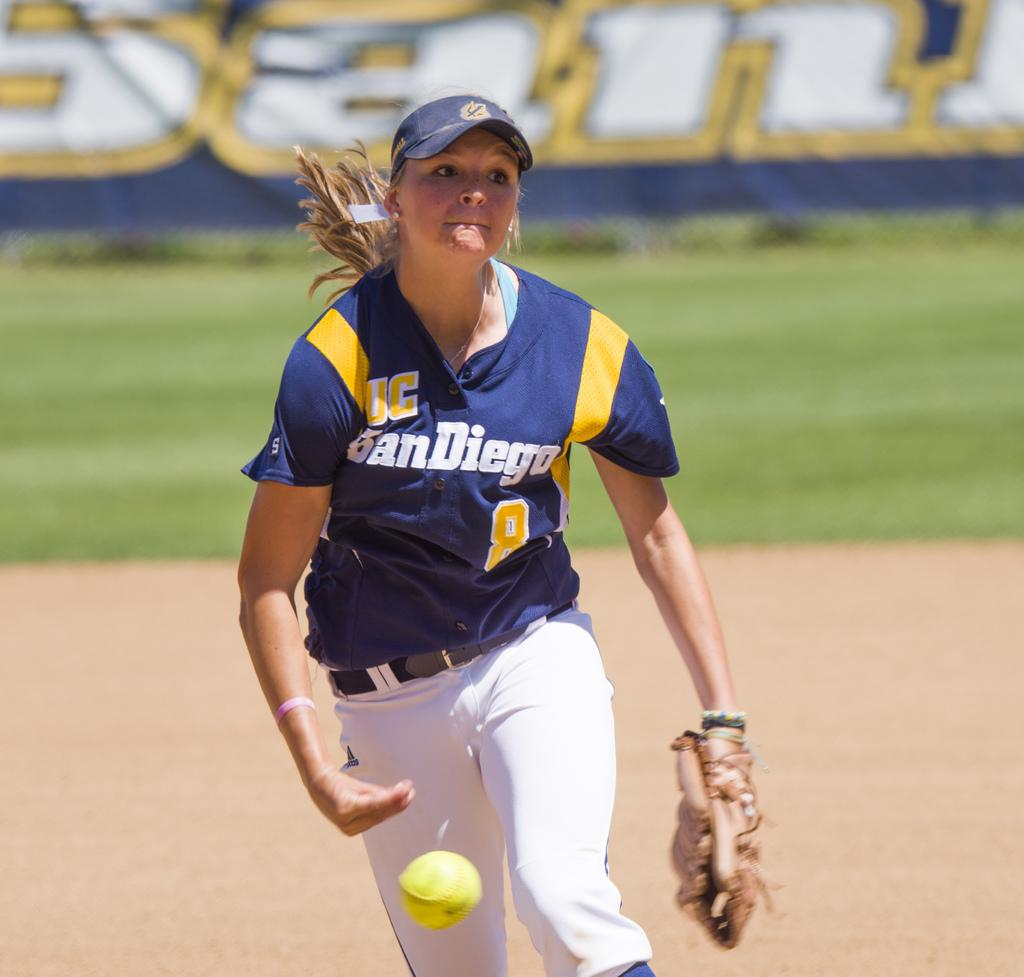Provide a one-sentence caption for the provided image. a player with the name san diego on their jersey. 